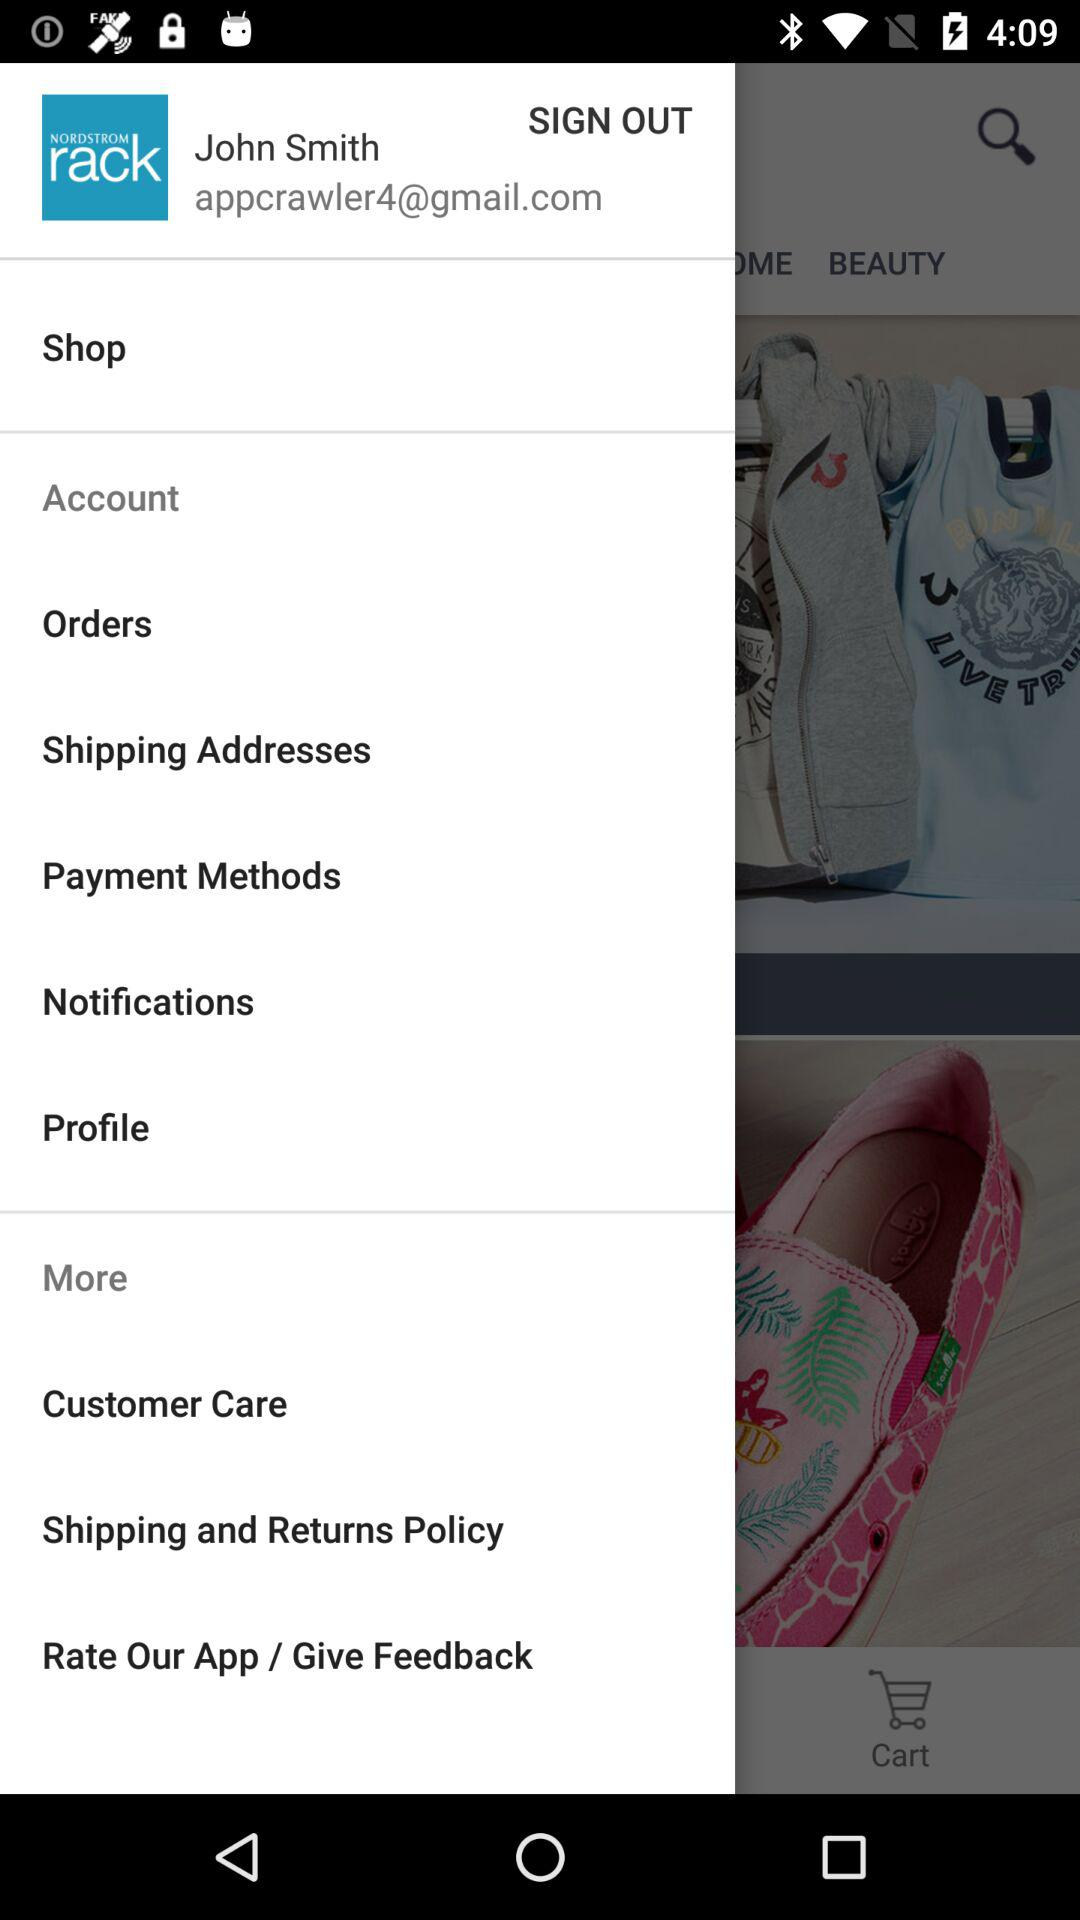What is the username? The username is "John Smith". 